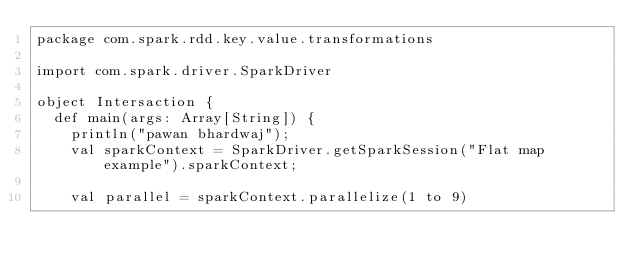<code> <loc_0><loc_0><loc_500><loc_500><_Scala_>package com.spark.rdd.key.value.transformations

import com.spark.driver.SparkDriver

object Intersaction {
  def main(args: Array[String]) {
    println("pawan bhardwaj");
    val sparkContext = SparkDriver.getSparkSession("Flat map example").sparkContext;

    val parallel = sparkContext.parallelize(1 to 9)</code> 